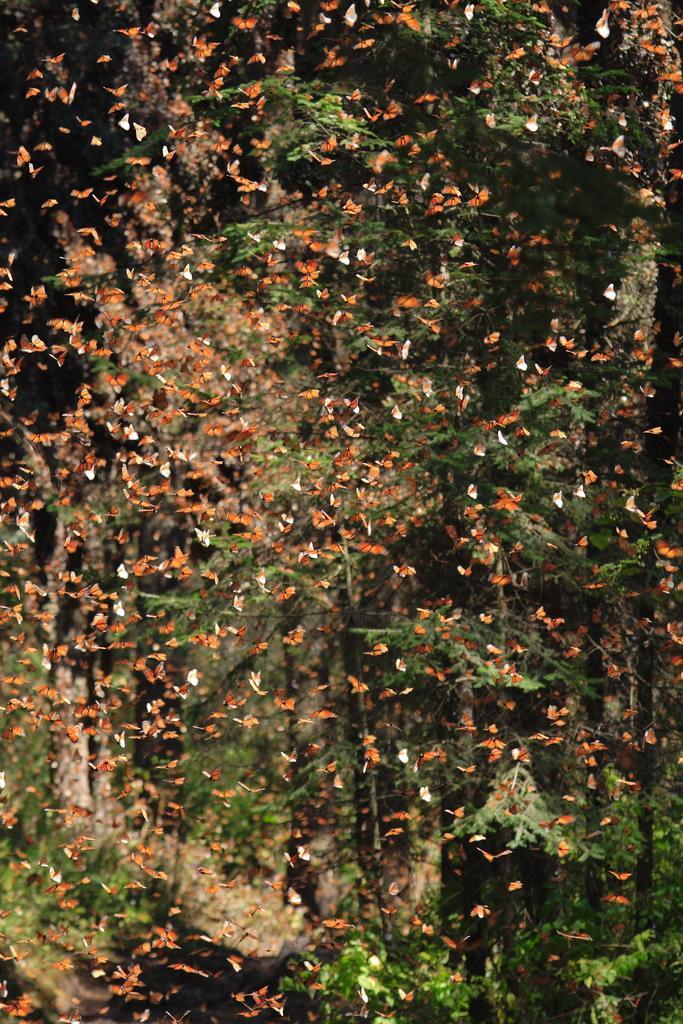Could you give a brief overview of what you see in this image? In this image, we can see butterflies flying and in the background, there are trees. 